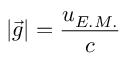<formula> <loc_0><loc_0><loc_500><loc_500>| \vec { g } | = \frac { u _ { E . M . } } c</formula> 